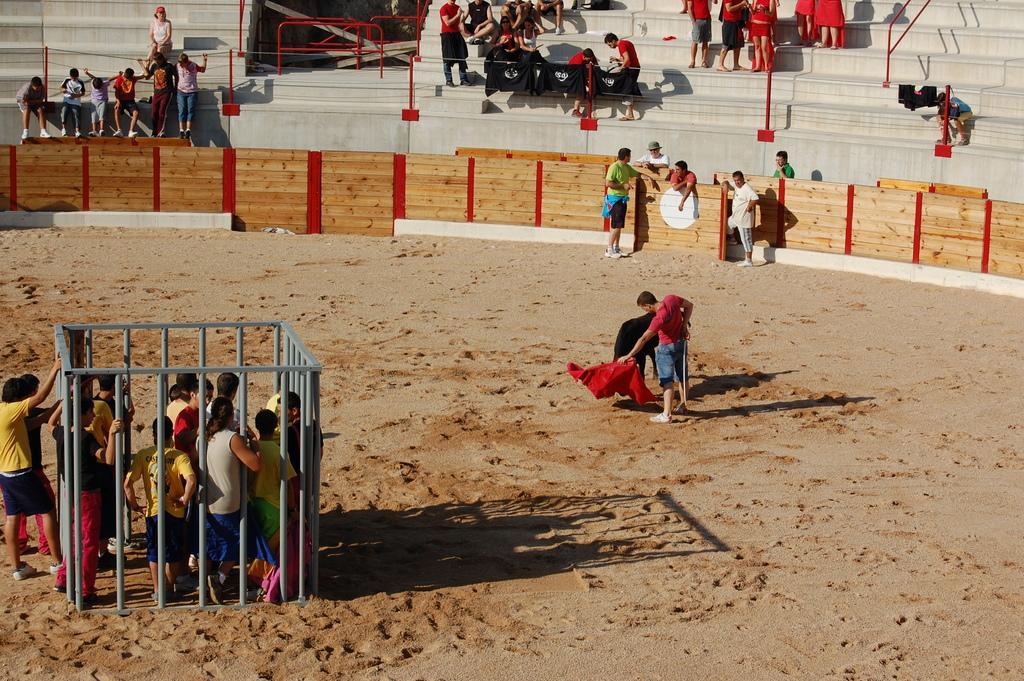How would you summarize this image in a sentence or two? In this image I can see there are a few people standing in the playground and there is a cage around few persons. There are audience sitting on the stairs. 